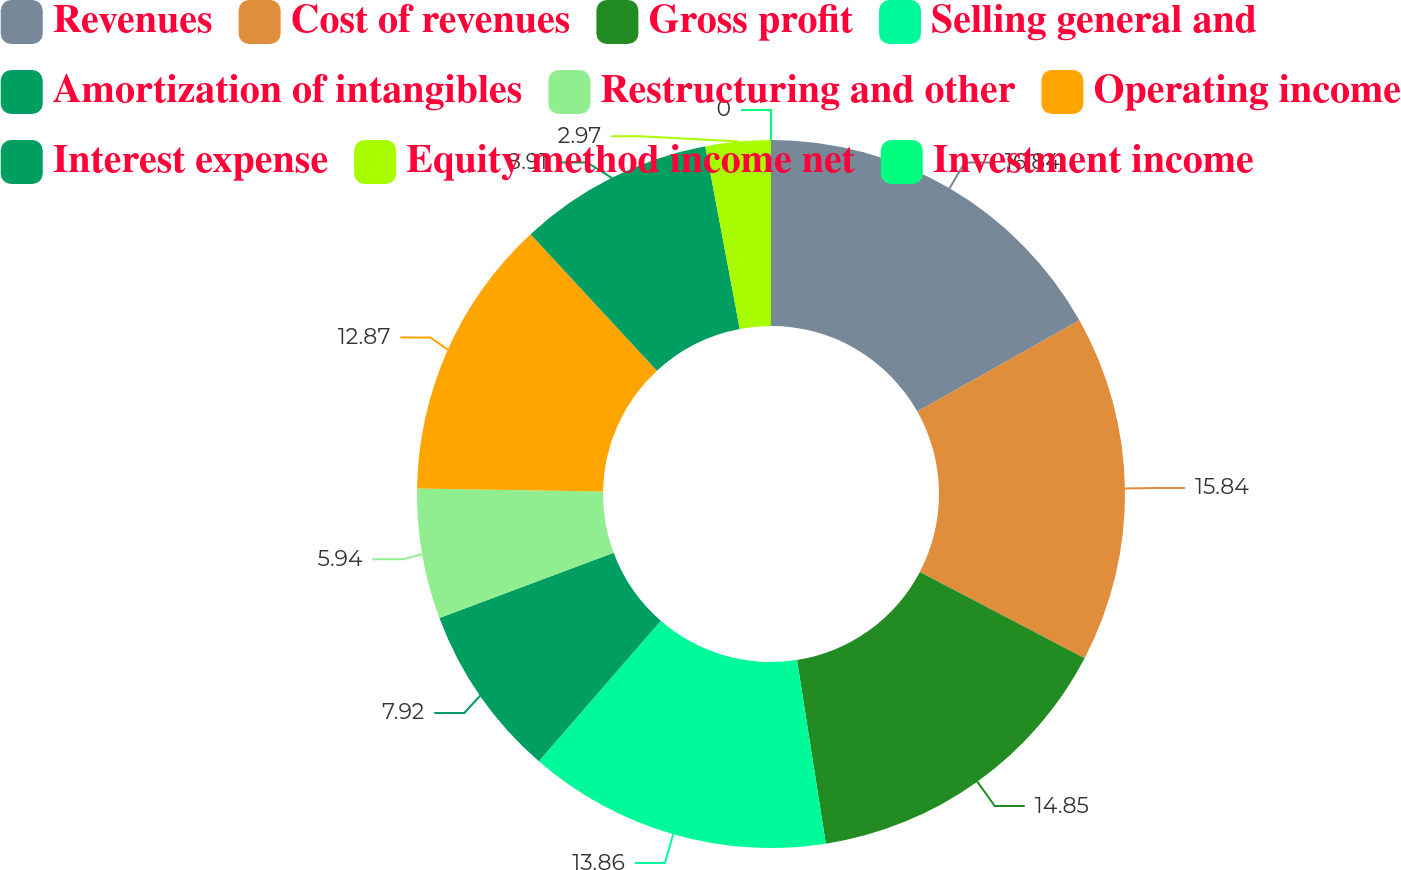<chart> <loc_0><loc_0><loc_500><loc_500><pie_chart><fcel>Revenues<fcel>Cost of revenues<fcel>Gross profit<fcel>Selling general and<fcel>Amortization of intangibles<fcel>Restructuring and other<fcel>Operating income<fcel>Interest expense<fcel>Equity method income net<fcel>Investment income<nl><fcel>16.83%<fcel>15.84%<fcel>14.85%<fcel>13.86%<fcel>7.92%<fcel>5.94%<fcel>12.87%<fcel>8.91%<fcel>2.97%<fcel>0.0%<nl></chart> 